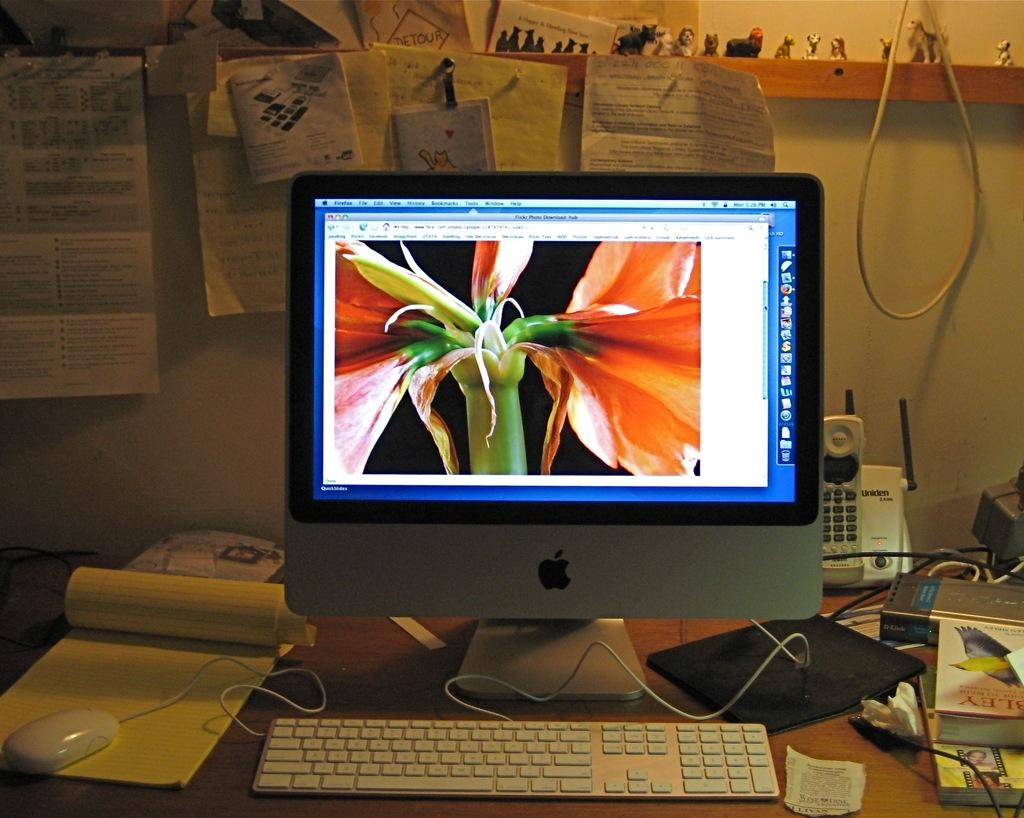What is located in the foreground of the image? There is a table in the foreground of the image. What electronic device is on the table? A computer is present on the table. What accessory is on the table for the computer? A mouse is on the table. What communication device is on the table? A phone is on the table. What reading materials are on the table? There are books on the table. What can be seen at the top of the image? Papers and small statues are present at the top of the image. Can you see a rifle on the table in the image? There is no rifle present on the table in the image. Are there any bees buzzing around the computer in the image? There are no bees visible in the image. 